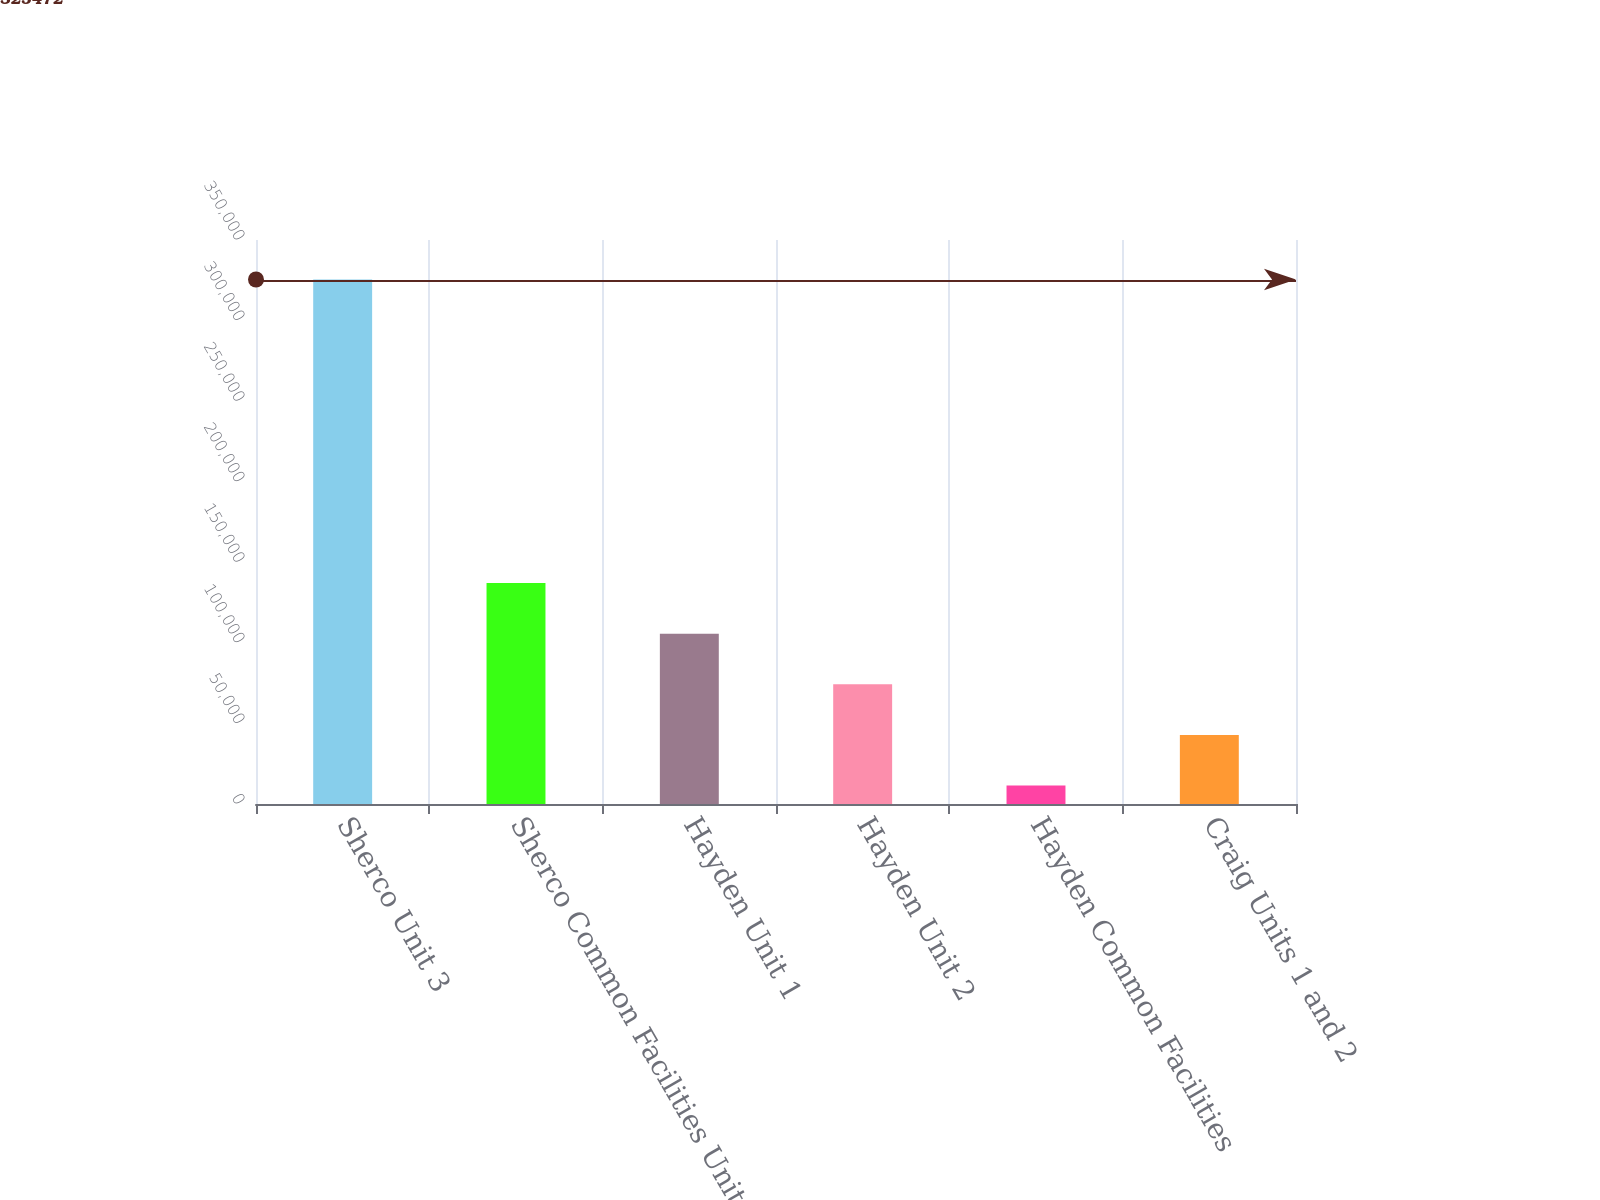Convert chart to OTSL. <chart><loc_0><loc_0><loc_500><loc_500><bar_chart><fcel>Sherco Unit 3<fcel>Sherco Common Facilities Units<fcel>Hayden Unit 1<fcel>Hayden Unit 2<fcel>Hayden Common Facilities<fcel>Craig Units 1 and 2<nl><fcel>325472<fcel>137076<fcel>105677<fcel>74277.6<fcel>11479<fcel>42878.3<nl></chart> 